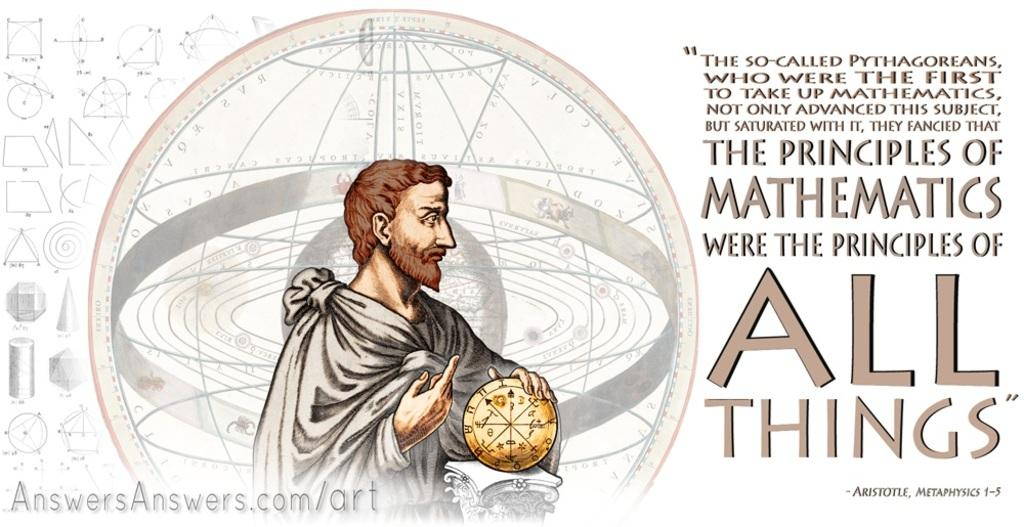What is the person's hand touching in the image? There is a person's hand on an object in the image. What can be seen in the background of the image? There are shapes visible in the background. What is written on the shapes in the background? Something is written on the shapes in the background. What is the color of the background in the image? The background color is white. What type of chin can be seen on the person in the image? There is no person's face visible in the image, only a hand on an object. What level of detail can be observed on the shapes in the background? The level of detail on the shapes in the background cannot be determined from the image alone, as it only shows their presence and that something is written on them. 